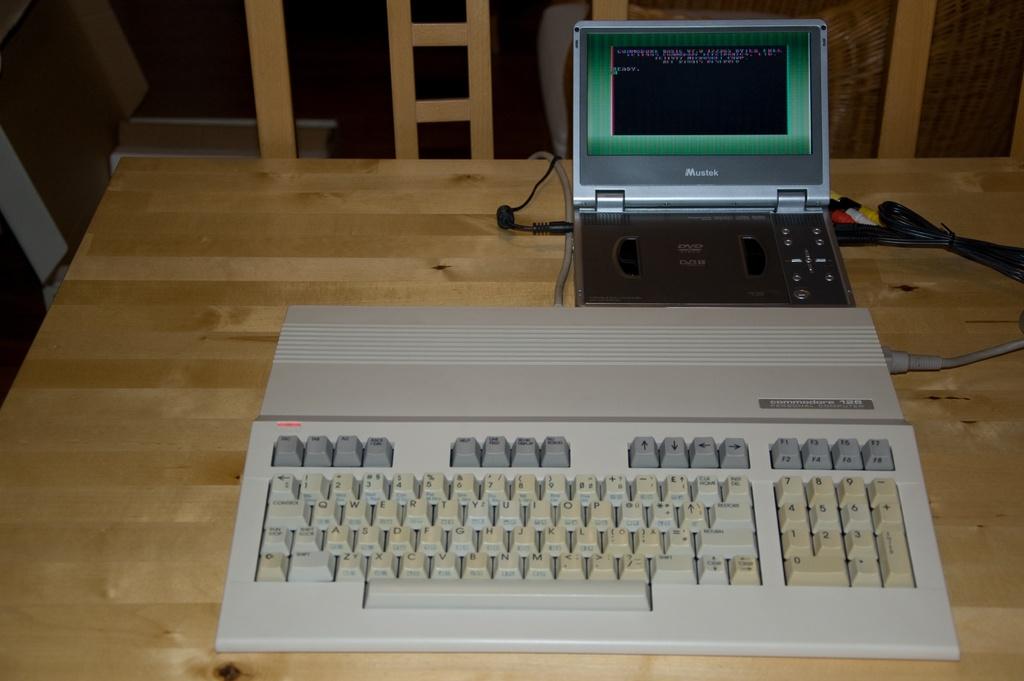Does this keyboard have a number pad?
Ensure brevity in your answer.  Yes. What is one of the numbers seen on the keyboard?
Give a very brief answer. 1. 